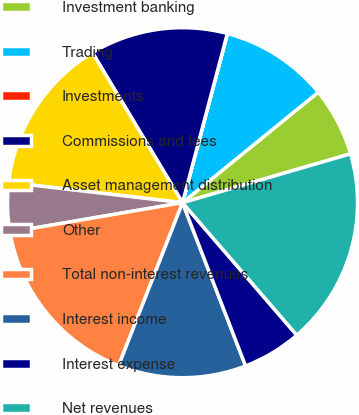Convert chart to OTSL. <chart><loc_0><loc_0><loc_500><loc_500><pie_chart><fcel>Investment banking<fcel>Trading<fcel>Investments<fcel>Commissions and fees<fcel>Asset management distribution<fcel>Other<fcel>Total non-interest revenues<fcel>Interest income<fcel>Interest expense<fcel>Net revenues<nl><fcel>6.37%<fcel>10.0%<fcel>0.01%<fcel>12.73%<fcel>14.54%<fcel>4.55%<fcel>16.36%<fcel>11.82%<fcel>5.46%<fcel>18.18%<nl></chart> 